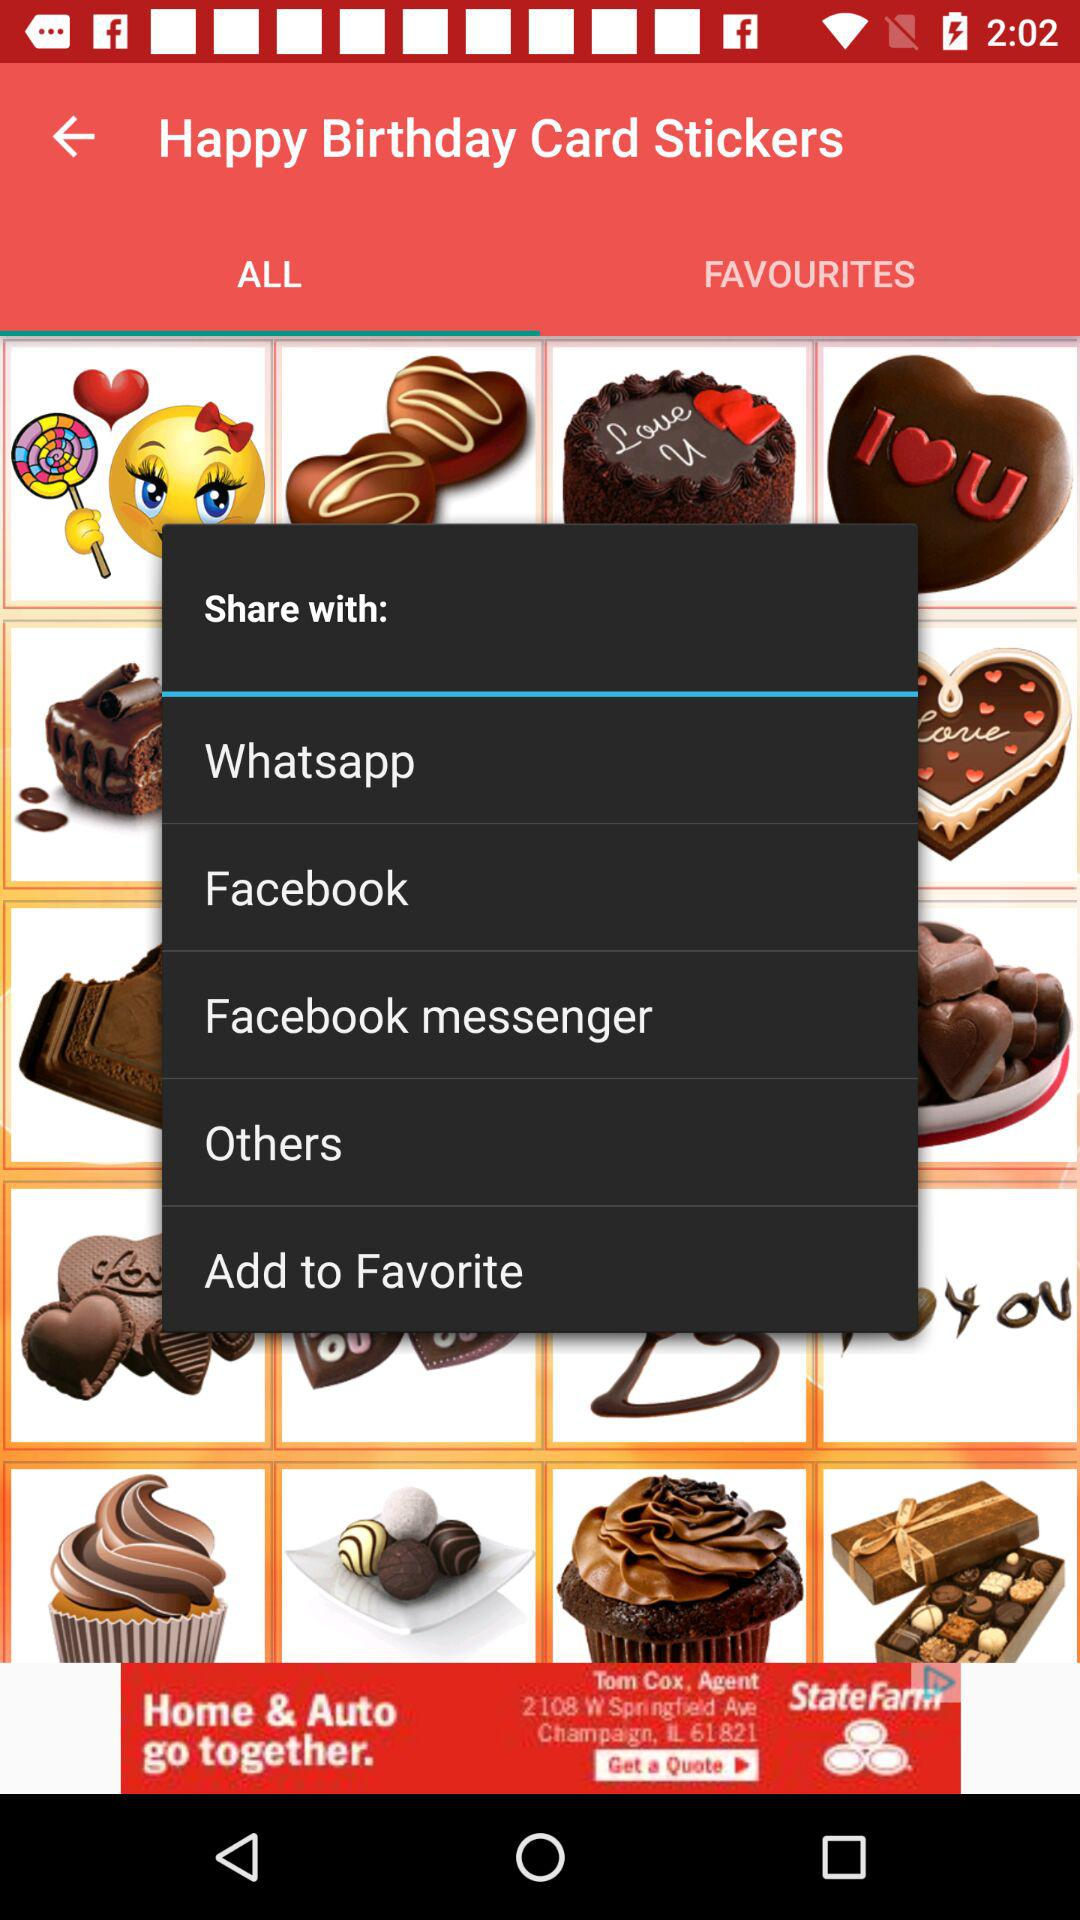Which application is selected to share the content?
When the provided information is insufficient, respond with <no answer>. <no answer> 